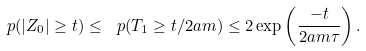Convert formula to latex. <formula><loc_0><loc_0><loc_500><loc_500>\ p ( | Z _ { 0 } | \geq t ) \leq \ p ( T _ { 1 } \geq t / 2 a m ) \leq 2 \exp \left ( \frac { - t } { 2 a m \tau } \right ) .</formula> 